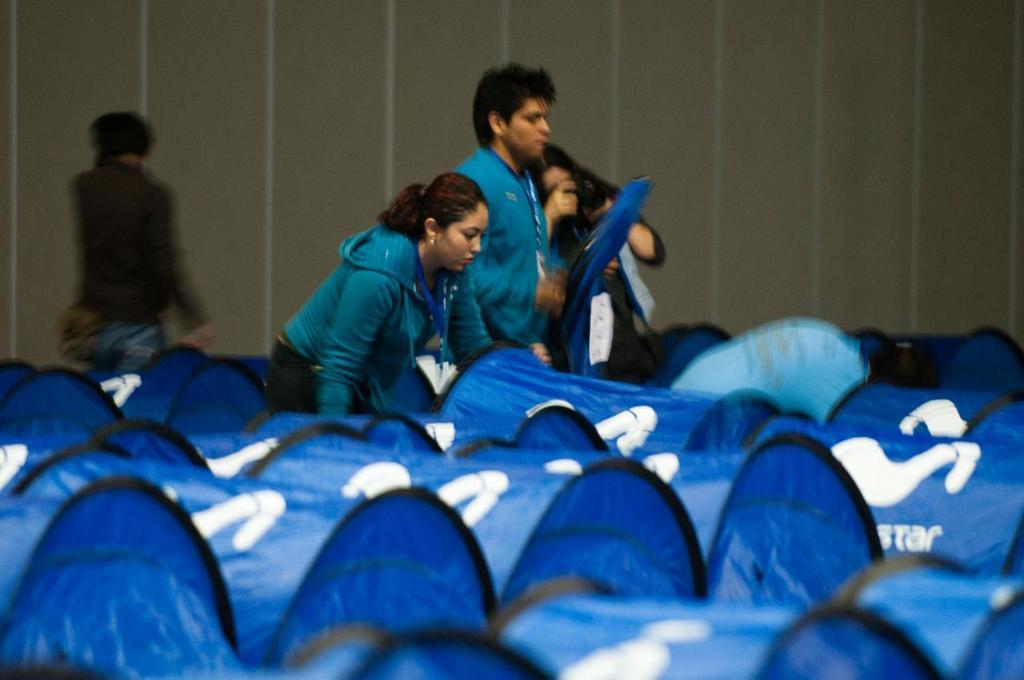How would you summarize this image in a sentence or two? In this image there are objects towards the bottom of the image that looks like bags, there is text on the bag, there is a woman holding a bag, there is a man holding a bag, there is a woman taking a photograph, there is a man walking, there is the wall towards the top of the image. 